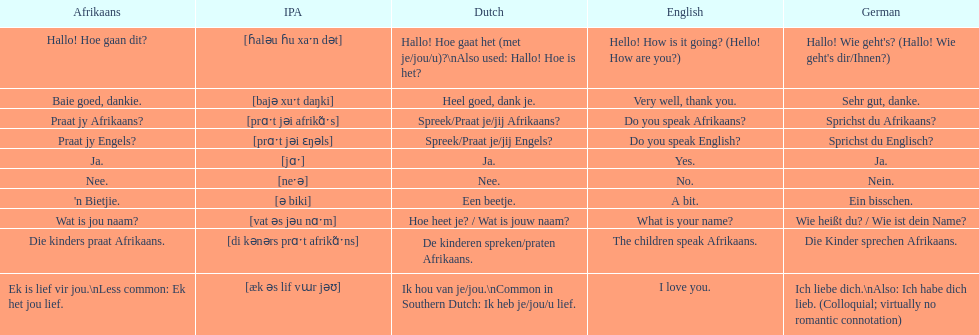Translate the following into english: 'n bietjie. A bit. 